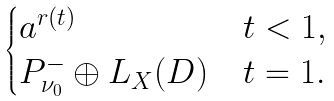Convert formula to latex. <formula><loc_0><loc_0><loc_500><loc_500>\begin{cases} \L a ^ { r ( t ) } & t < 1 , \\ P ^ { - } _ { \nu _ { 0 } } \oplus L _ { X } ( D ) & t = 1 . \end{cases}</formula> 